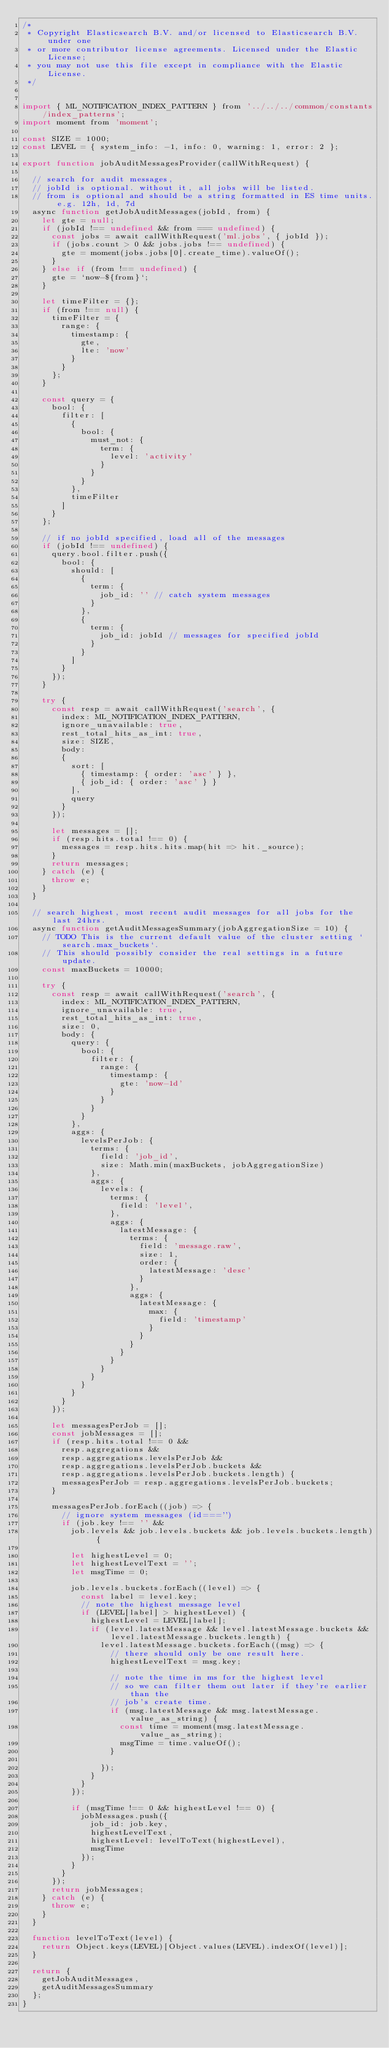Convert code to text. <code><loc_0><loc_0><loc_500><loc_500><_JavaScript_>/*
 * Copyright Elasticsearch B.V. and/or licensed to Elasticsearch B.V. under one
 * or more contributor license agreements. Licensed under the Elastic License;
 * you may not use this file except in compliance with the Elastic License.
 */


import { ML_NOTIFICATION_INDEX_PATTERN } from '../../../common/constants/index_patterns';
import moment from 'moment';

const SIZE = 1000;
const LEVEL = { system_info: -1, info: 0, warning: 1, error: 2 };

export function jobAuditMessagesProvider(callWithRequest) {

  // search for audit messages,
  // jobId is optional. without it, all jobs will be listed.
  // from is optional and should be a string formatted in ES time units. e.g. 12h, 1d, 7d
  async function getJobAuditMessages(jobId, from) {
    let gte = null;
    if (jobId !== undefined && from === undefined) {
      const jobs = await callWithRequest('ml.jobs', { jobId });
      if (jobs.count > 0 && jobs.jobs !== undefined) {
        gte = moment(jobs.jobs[0].create_time).valueOf();
      }
    } else if (from !== undefined) {
      gte = `now-${from}`;
    }

    let timeFilter = {};
    if (from !== null) {
      timeFilter = {
        range: {
          timestamp: {
            gte,
            lte: 'now'
          }
        }
      };
    }

    const query = {
      bool: {
        filter: [
          {
            bool: {
              must_not: {
                term: {
                  level: 'activity'
                }
              }
            }
          },
          timeFilter
        ]
      }
    };

    // if no jobId specified, load all of the messages
    if (jobId !== undefined) {
      query.bool.filter.push({
        bool: {
          should: [
            {
              term: {
                job_id: '' // catch system messages
              }
            },
            {
              term: {
                job_id: jobId // messages for specified jobId
              }
            }
          ]
        }
      });
    }

    try {
      const resp = await callWithRequest('search', {
        index: ML_NOTIFICATION_INDEX_PATTERN,
        ignore_unavailable: true,
        rest_total_hits_as_int: true,
        size: SIZE,
        body:
        {
          sort: [
            { timestamp: { order: 'asc' } },
            { job_id: { order: 'asc' } }
          ],
          query
        }
      });

      let messages = [];
      if (resp.hits.total !== 0) {
        messages = resp.hits.hits.map(hit => hit._source);
      }
      return messages;
    } catch (e) {
      throw e;
    }
  }

  // search highest, most recent audit messages for all jobs for the last 24hrs.
  async function getAuditMessagesSummary(jobAggregationSize = 10) {
    // TODO This is the current default value of the cluster setting `search.max_buckets`.
    // This should possibly consider the real settings in a future update.
    const maxBuckets = 10000;

    try {
      const resp = await callWithRequest('search', {
        index: ML_NOTIFICATION_INDEX_PATTERN,
        ignore_unavailable: true,
        rest_total_hits_as_int: true,
        size: 0,
        body: {
          query: {
            bool: {
              filter: {
                range: {
                  timestamp: {
                    gte: 'now-1d'
                  }
                }
              }
            }
          },
          aggs: {
            levelsPerJob: {
              terms: {
                field: 'job_id',
                size: Math.min(maxBuckets, jobAggregationSize)
              },
              aggs: {
                levels: {
                  terms: {
                    field: 'level',
                  },
                  aggs: {
                    latestMessage: {
                      terms: {
                        field: 'message.raw',
                        size: 1,
                        order: {
                          latestMessage: 'desc'
                        }
                      },
                      aggs: {
                        latestMessage: {
                          max: {
                            field: 'timestamp'
                          }
                        }
                      }
                    }
                  }
                }
              }
            }
          }
        }
      });

      let messagesPerJob = [];
      const jobMessages = [];
      if (resp.hits.total !== 0 &&
        resp.aggregations &&
        resp.aggregations.levelsPerJob &&
        resp.aggregations.levelsPerJob.buckets &&
        resp.aggregations.levelsPerJob.buckets.length) {
        messagesPerJob = resp.aggregations.levelsPerJob.buckets;
      }

      messagesPerJob.forEach((job) => {
        // ignore system messages (id==='')
        if (job.key !== '' &&
          job.levels && job.levels.buckets && job.levels.buckets.length) {

          let highestLevel = 0;
          let highestLevelText = '';
          let msgTime = 0;

          job.levels.buckets.forEach((level) => {
            const label = level.key;
            // note the highest message level
            if (LEVEL[label] > highestLevel) {
              highestLevel = LEVEL[label];
              if (level.latestMessage && level.latestMessage.buckets && level.latestMessage.buckets.length) {
                level.latestMessage.buckets.forEach((msg) => {
                  // there should only be one result here.
                  highestLevelText = msg.key;

                  // note the time in ms for the highest level
                  // so we can filter them out later if they're earlier than the
                  // job's create time.
                  if (msg.latestMessage && msg.latestMessage.value_as_string) {
                    const time = moment(msg.latestMessage.value_as_string);
                    msgTime = time.valueOf();
                  }

                });
              }
            }
          });

          if (msgTime !== 0 && highestLevel !== 0) {
            jobMessages.push({
              job_id: job.key,
              highestLevelText,
              highestLevel: levelToText(highestLevel),
              msgTime
            });
          }
        }
      });
      return jobMessages;
    } catch (e) {
      throw e;
    }
  }

  function levelToText(level) {
    return Object.keys(LEVEL)[Object.values(LEVEL).indexOf(level)];
  }

  return {
    getJobAuditMessages,
    getAuditMessagesSummary
  };
}
</code> 